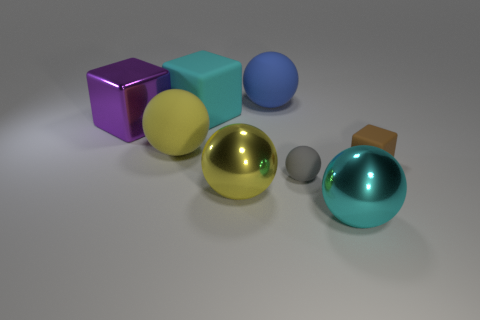What number of other things are the same shape as the purple thing?
Your answer should be very brief. 2. Is the color of the ball to the left of the big matte block the same as the big shiny thing that is left of the big cyan block?
Ensure brevity in your answer.  No. What color is the object that is the same size as the gray rubber ball?
Ensure brevity in your answer.  Brown. Is there another small ball of the same color as the tiny ball?
Offer a terse response. No. There is a yellow sphere that is behind the yellow metal ball; is it the same size as the blue rubber ball?
Offer a terse response. Yes. Are there the same number of large blue rubber things that are in front of the cyan metallic object and metallic spheres?
Provide a succinct answer. No. How many objects are shiny objects behind the brown cube or large yellow balls?
Give a very brief answer. 3. The big object that is right of the large yellow shiny sphere and in front of the blue rubber ball has what shape?
Provide a short and direct response. Sphere. How many things are either cubes on the right side of the large purple metallic thing or metal things that are to the right of the large rubber block?
Offer a very short reply. 4. How many other things are the same size as the cyan ball?
Ensure brevity in your answer.  5. 